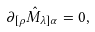Convert formula to latex. <formula><loc_0><loc_0><loc_500><loc_500>\partial _ { [ \rho } \hat { M } _ { \lambda ] \alpha } = 0 ,</formula> 